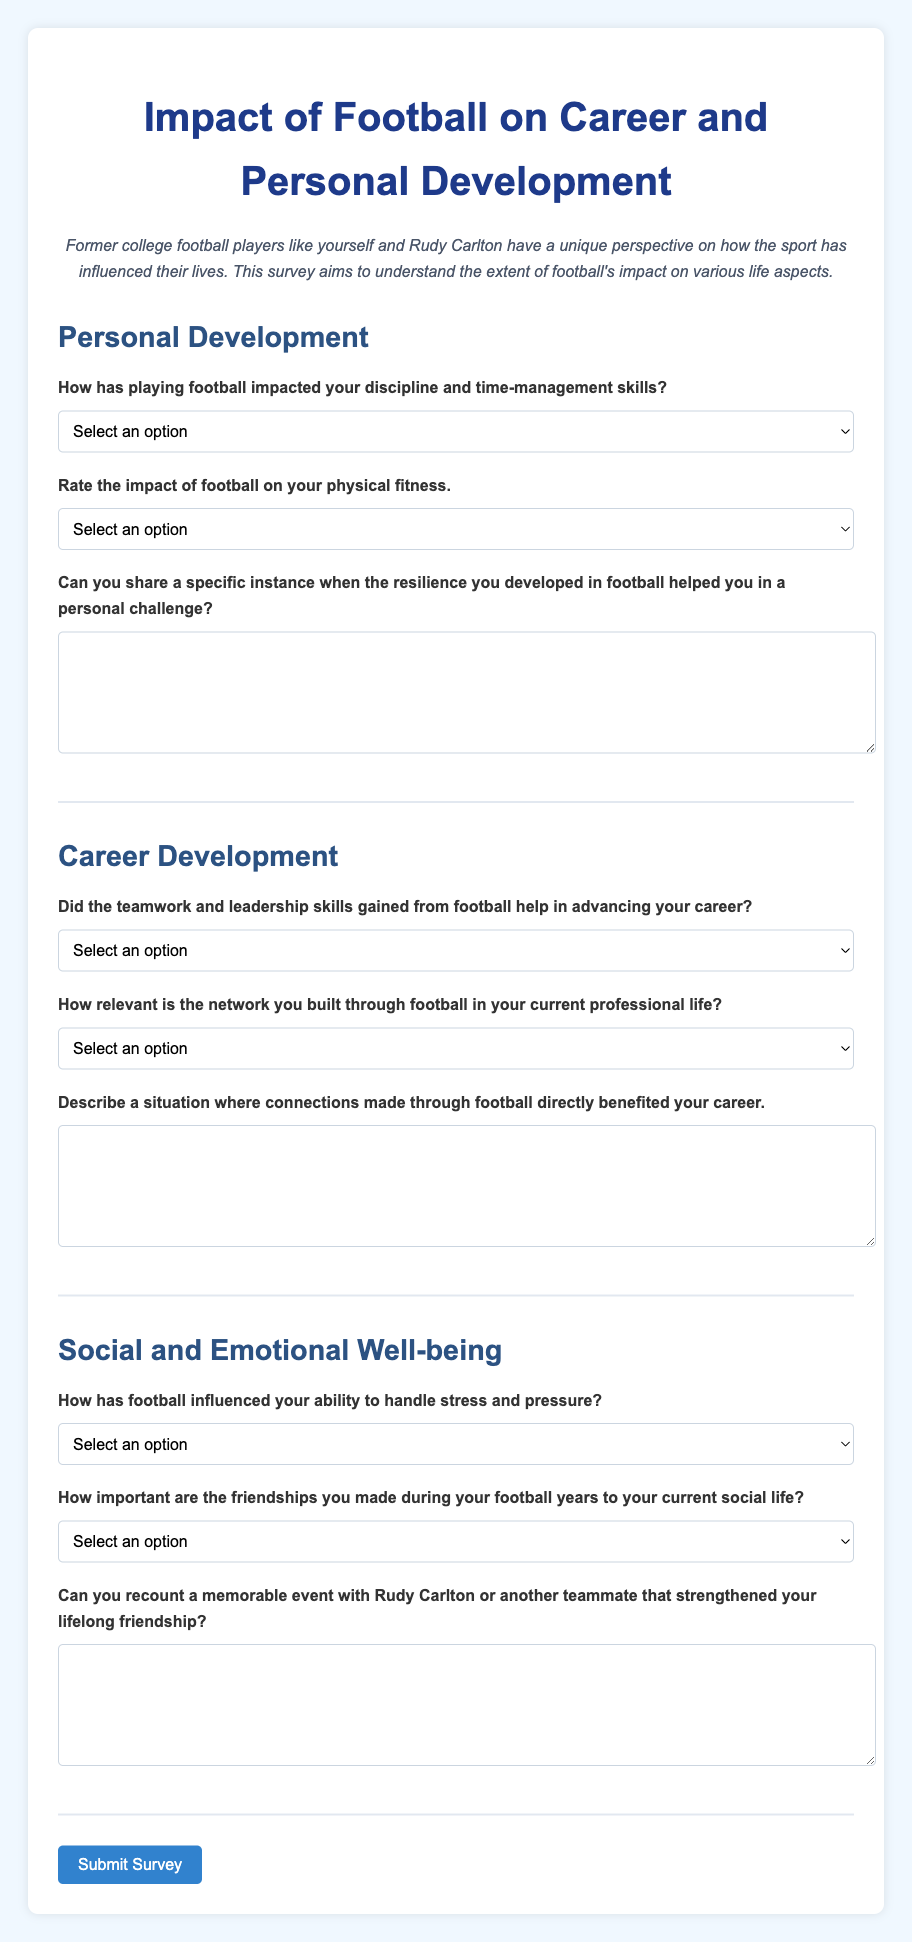What is the title of the survey? The title of the survey is prominently displayed at the top of the document, which is "Impact of Football on Career and Personal Development."
Answer: Impact of Football on Career and Personal Development How many sections are in the survey? The survey consists of three sections: Personal Development, Career Development, and Social and Emotional Well-being.
Answer: Three What type of question is asked regarding resilience? The question asks for a specific instance of when resilience developed in football helped in a personal challenge, requiring a descriptive response.
Answer: Describe a specific instance What is the response format for each question? Each question allows different response formats including selection from options or providing written descriptions through text areas.
Answer: Select an option or provide a text response How is the visual design of the survey described? The visual design includes a max width of 800 pixels, centered content, and a background color of light blue (#f0f8ff).
Answer: Light blue background What is the purpose of this survey? The purpose of the survey is to understand the extent of football's impact on various aspects of life for former players.
Answer: Understand the impact of football What kind of responses can participants give about their fitness? Participants can select from five options regarding the impact of football on their physical fitness, ranging from highly beneficial to highly detrimental.
Answer: Five options related to fitness What does the button at the end of the form do? The button allows respondents to submit their completed survey responses.
Answer: Submit Survey 